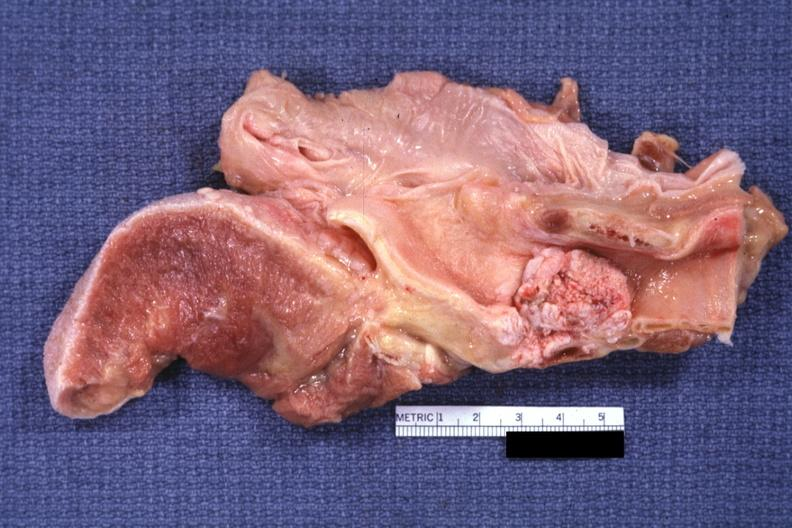does this image show large fungating lesion?
Answer the question using a single word or phrase. Yes 